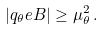<formula> <loc_0><loc_0><loc_500><loc_500>\left | q _ { \theta } e B \right | \geq \mu ^ { 2 } _ { \theta } \, .</formula> 